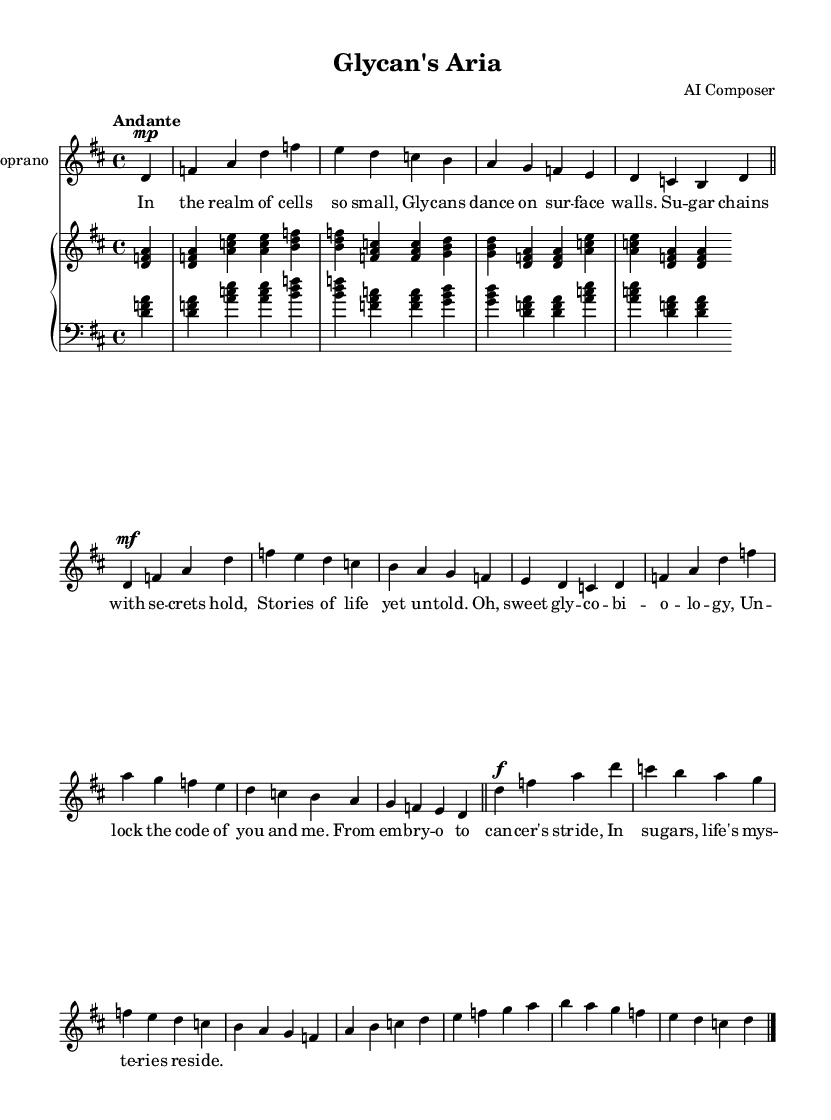What is the key signature of this music? The key signature at the beginning of the score shows two sharps, indicating D major.
Answer: D major What is the time signature of the piece? The time signature is indicated at the beginning of the score as 4/4, which means there are four beats in each measure.
Answer: 4/4 What is the tempo marking for the piece? The tempo marking is "Andante," suggesting a moderately slow pace for the performance.
Answer: Andante How many measures are in the verse section? The verse section contains a series of musical phrases, and upon counting the measures, there are 4 measures.
Answer: 4 What is the dynamic marking for the chorus? The dynamic marking for the chorus is marked as forte (f), indicating a strong, loud sound.
Answer: forte What is the main theme expressed in the lyrics? The lyrics express a celebration of glycobiology and its importance in life, highlighting the mysteries and stories held in sugar chains.
Answer: Glycobiology What kind of vocal range is indicated for the main part? The main vocal part is labeled as "Soprano," indicating that it is meant for higher vocal range typical of female vocalists.
Answer: Soprano 